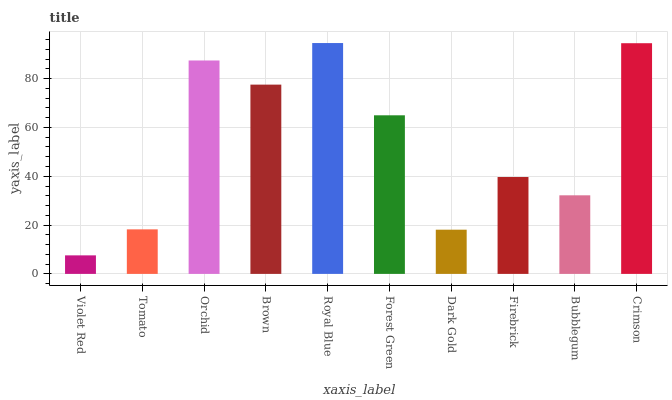Is Violet Red the minimum?
Answer yes or no. Yes. Is Royal Blue the maximum?
Answer yes or no. Yes. Is Tomato the minimum?
Answer yes or no. No. Is Tomato the maximum?
Answer yes or no. No. Is Tomato greater than Violet Red?
Answer yes or no. Yes. Is Violet Red less than Tomato?
Answer yes or no. Yes. Is Violet Red greater than Tomato?
Answer yes or no. No. Is Tomato less than Violet Red?
Answer yes or no. No. Is Forest Green the high median?
Answer yes or no. Yes. Is Firebrick the low median?
Answer yes or no. Yes. Is Firebrick the high median?
Answer yes or no. No. Is Royal Blue the low median?
Answer yes or no. No. 